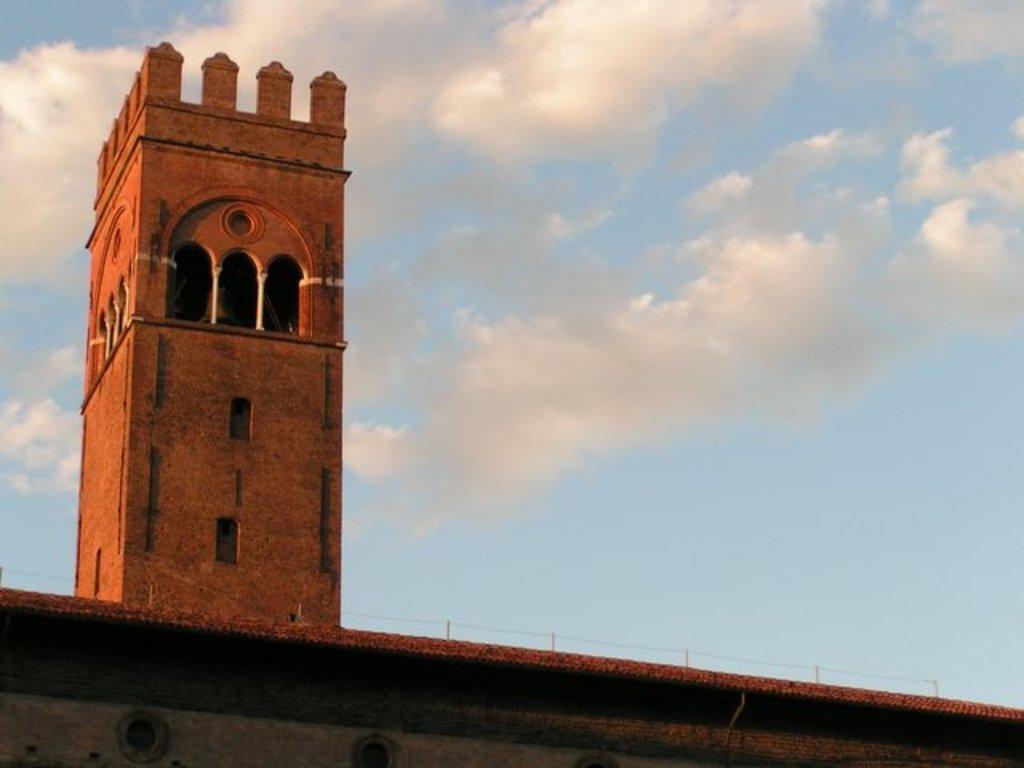In one or two sentences, can you explain what this image depicts? At the bottom of the image there is a building. Behind the building there are some clouds and sky. 